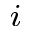Convert formula to latex. <formula><loc_0><loc_0><loc_500><loc_500>_ { i }</formula> 